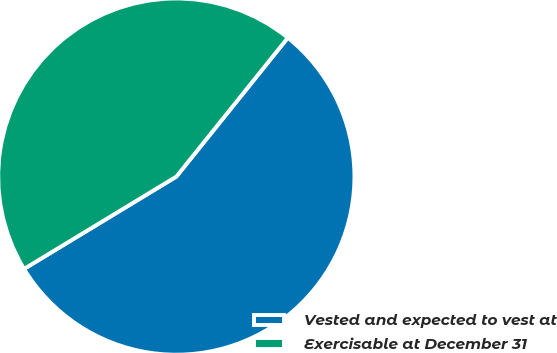<chart> <loc_0><loc_0><loc_500><loc_500><pie_chart><fcel>Vested and expected to vest at<fcel>Exercisable at December 31<nl><fcel>55.56%<fcel>44.44%<nl></chart> 